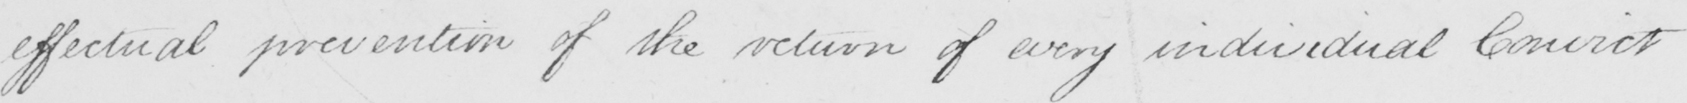What does this handwritten line say? effectual prevention of the return of every individual Convict 